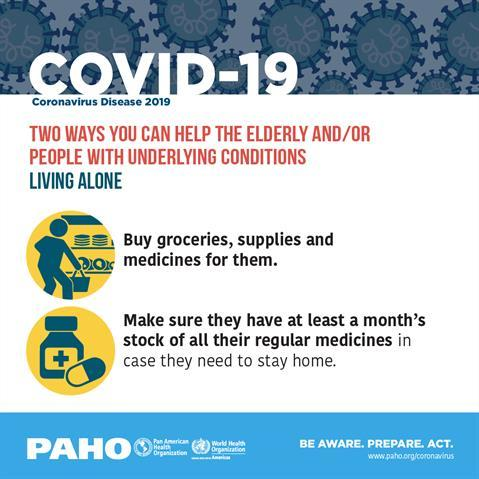Point out several critical features in this image. It is recommended to stockpile regular medications for at least one month to ensure adequate supply in the event of an unexpected disruption in access to pharmaceuticals. It is necessary to purchase groceries, supplies, and medicines for individuals who live alone. It is imperative that the elderly and individuals with underlying medical conditions who reside alone receive assistance with purchasing and stocking in order to maintain their health and well-being. 